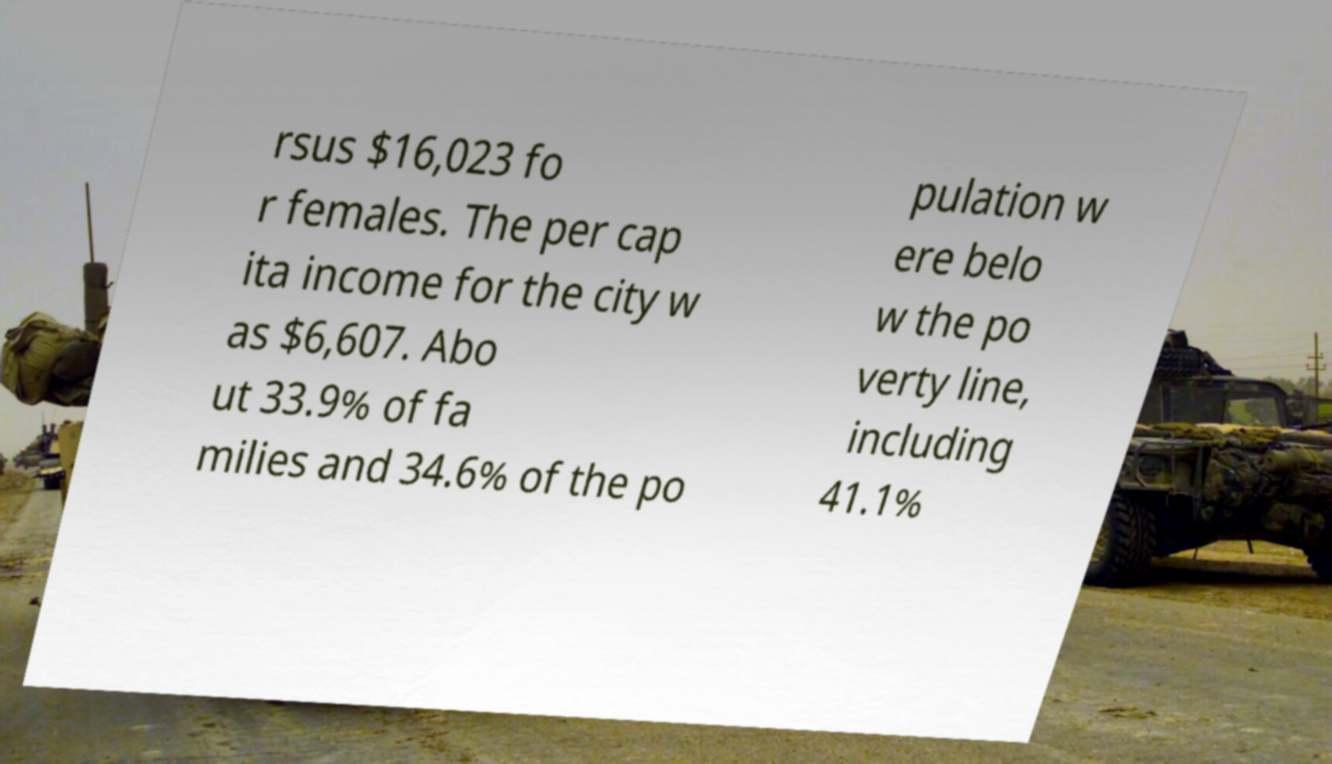Can you read and provide the text displayed in the image?This photo seems to have some interesting text. Can you extract and type it out for me? rsus $16,023 fo r females. The per cap ita income for the city w as $6,607. Abo ut 33.9% of fa milies and 34.6% of the po pulation w ere belo w the po verty line, including 41.1% 